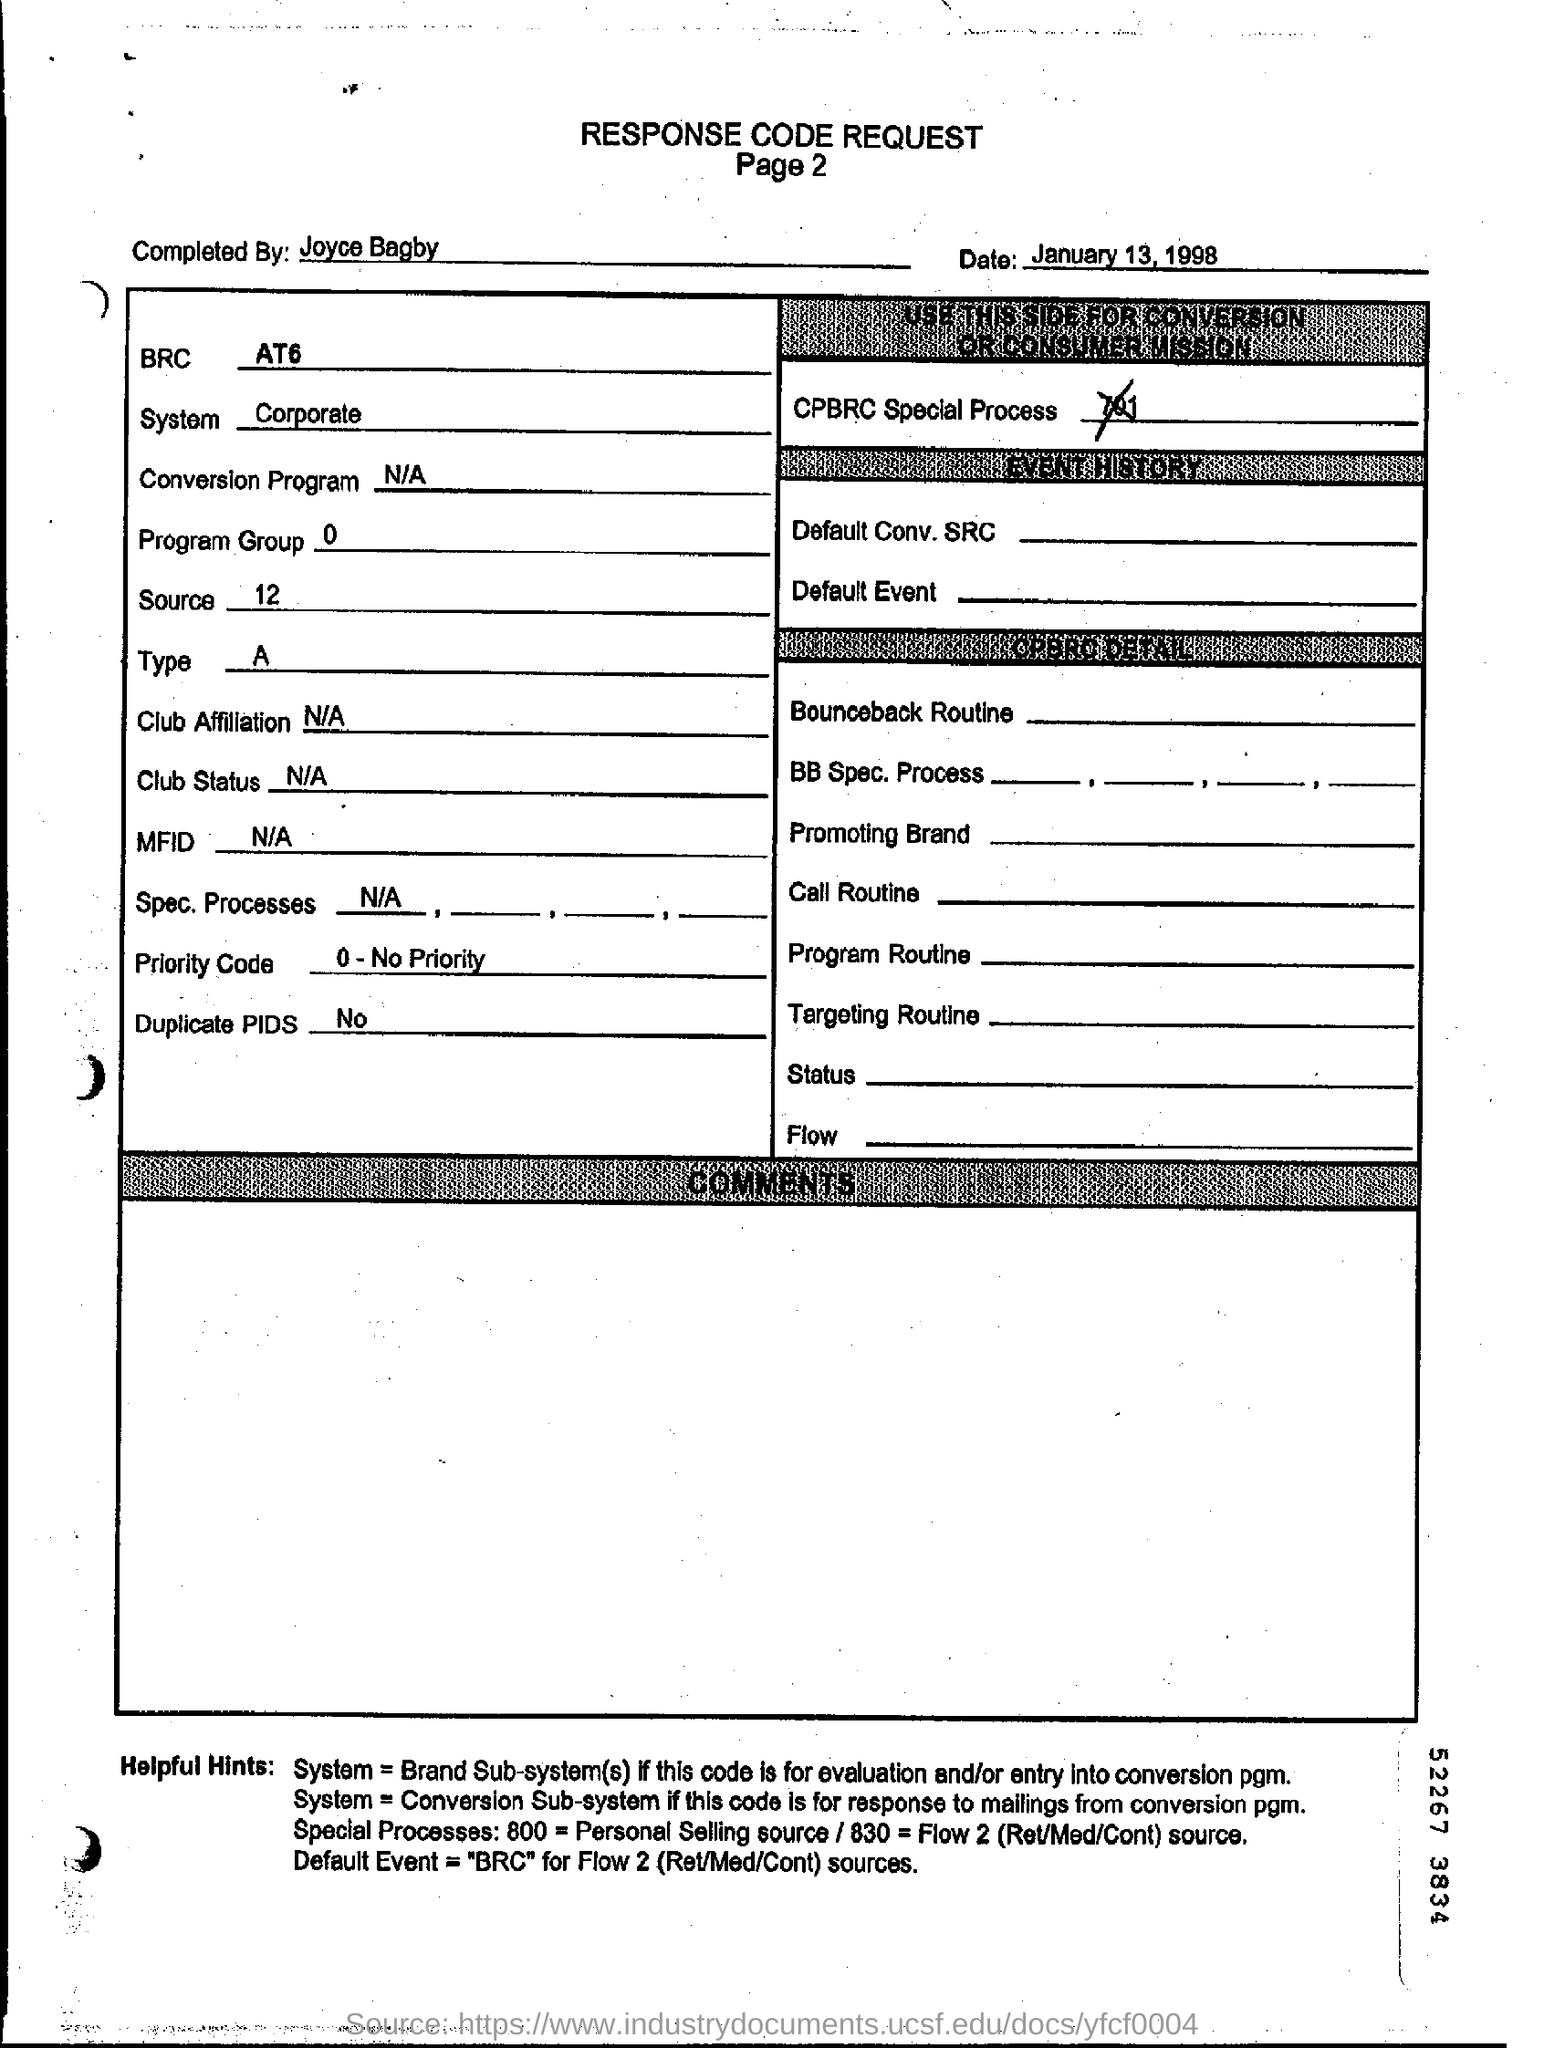List a handful of essential elements in this visual. The priority code indicates whether a task or request has a high or low priority. A priority code of 0 indicates that no priority has been assigned. The top of the document contains the response code request. The text that appears below the main heading of the document is stated on Page 2. The date mentioned at the top of the document is January 13, 1998. Joyce Bagby filled this form. 